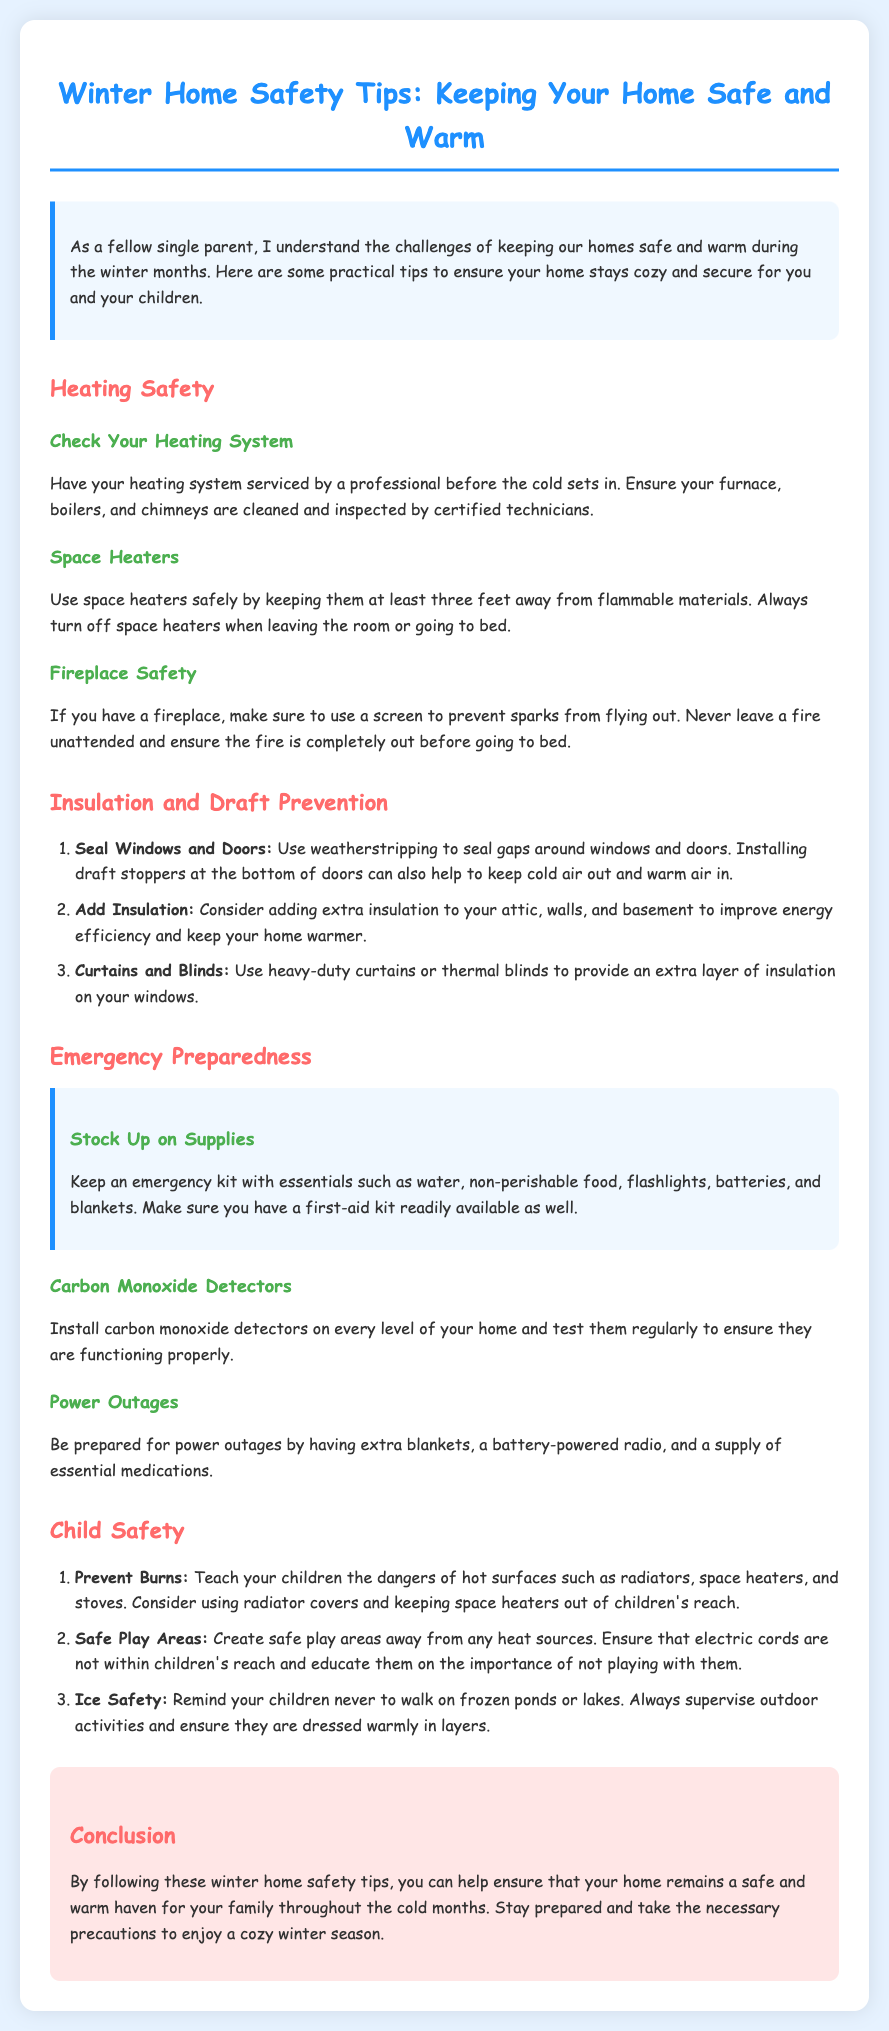What should you check in your heating system? The heating system should be serviced by a professional before the cold sets in.
Answer: Serviced by a professional What should you keep space heaters away from? Space heaters should be kept at least three feet away from flammable materials.
Answer: Flammable materials What should you do if you have a fireplace? Use a screen to prevent sparks from flying out and never leave a fire unattended.
Answer: Use a screen What are three supplies to have in an emergency kit? The emergency kit should include essentials such as water, non-perishable food, flashlights, batteries, and blankets.
Answer: Water, non-perishable food, flashlights How should you prevent burns for children? Teach your children the dangers of hot surfaces and consider using radiator covers.
Answer: Teach dangers of hot surfaces What can you add to improve insulation in your home? Consider adding extra insulation to your attic, walls, and basement.
Answer: Extra insulation What should you remind your children about frozen ponds? Remind your children never to walk on frozen ponds or lakes.
Answer: Never walk on frozen ponds How can weatherstripping help your home? Weatherstripping seals gaps around windows and doors, keeping cold air out and warm air in.
Answer: Seals gaps How often should carbon monoxide detectors be tested? Carbon monoxide detectors should be tested regularly to ensure they are functioning properly.
Answer: Regularly 